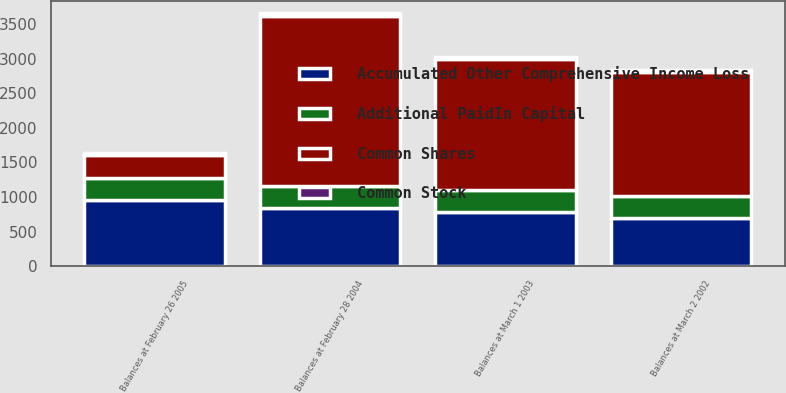Convert chart. <chart><loc_0><loc_0><loc_500><loc_500><stacked_bar_chart><ecel><fcel>Balances at March 2 2002<fcel>Balances at March 1 2003<fcel>Balances at February 28 2004<fcel>Balances at February 26 2005<nl><fcel>Additional PaidIn Capital<fcel>319<fcel>322<fcel>325<fcel>328<nl><fcel>Common Stock<fcel>31<fcel>32<fcel>32<fcel>33<nl><fcel>Accumulated Other Comprehensive Income Loss<fcel>702<fcel>778<fcel>836<fcel>952<nl><fcel>Common Shares<fcel>1794<fcel>1893<fcel>2468<fcel>328<nl></chart> 